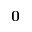Convert formula to latex. <formula><loc_0><loc_0><loc_500><loc_500>{ \mathbf 0 }</formula> 